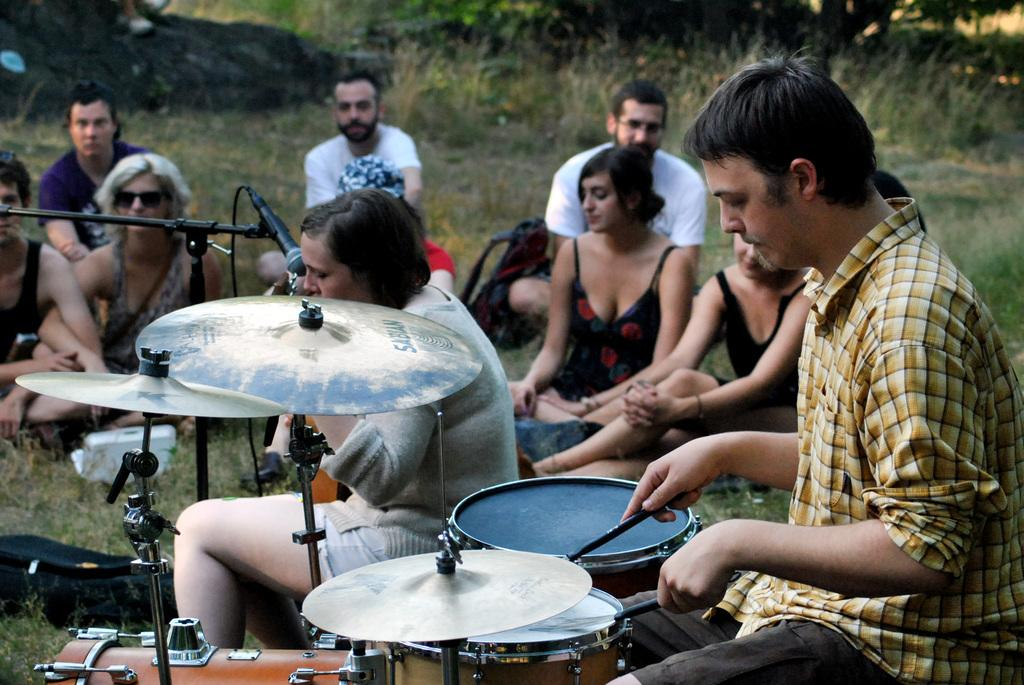What is the man in the image doing? The man is playing a drum in the image. What is the woman in the image doing? The woman is singing on a microphone in the image. How are the people in the image positioned? The people are sitting on the grass in the image. What are the people in the image focused on? The people are looking at the man and woman in the image. Can you see a robin flying over the people in the image? There is no robin present in the image. What type of cracker is the man holding while playing the drum? The man is not holding any cracker in the image; he is playing a drum. 